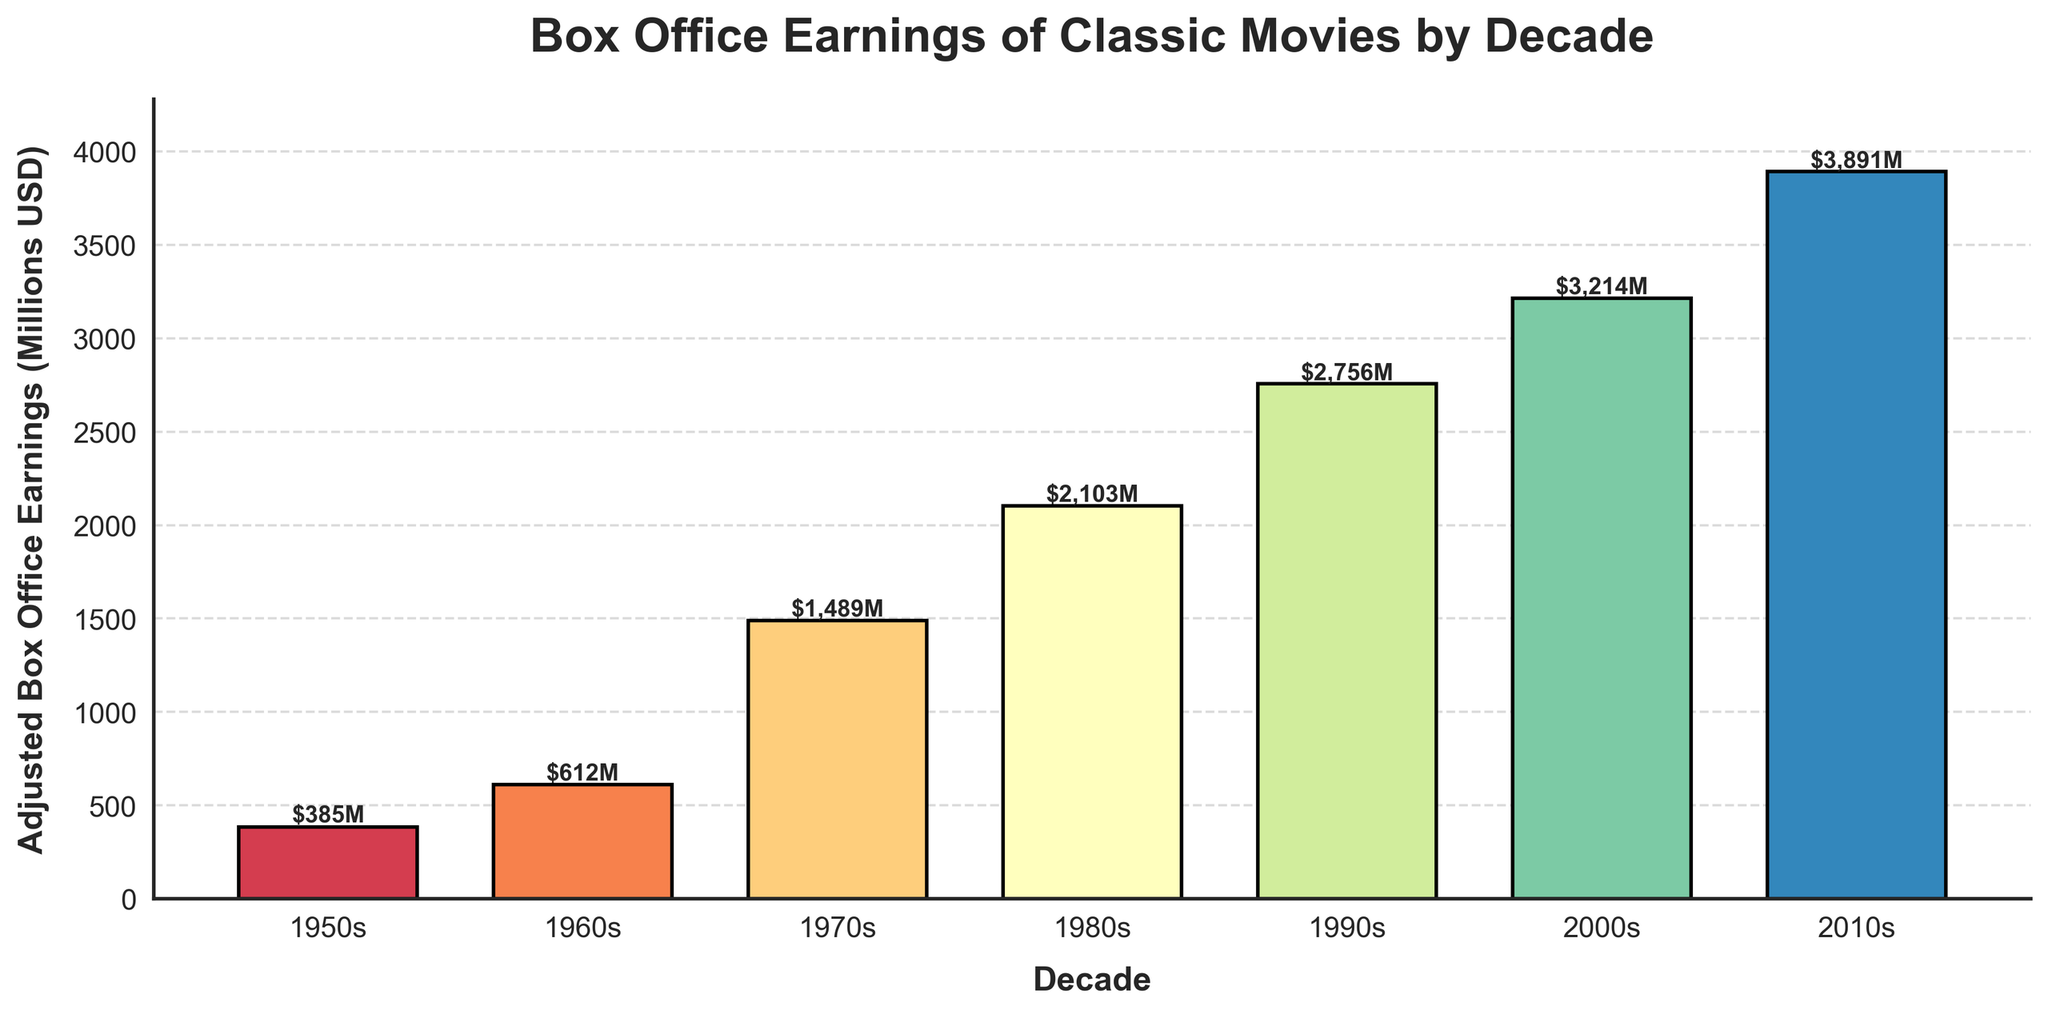Which decade had the highest box office earnings? To find the highest box office earnings, look for the bar that is the tallest. The decade of 2010s has the tallest bar.
Answer: 2010s Which decade had the lowest box office earnings? To find the lowest box office earnings, look for the bar that is the shortest. The 1950s decade has the shortest bar.
Answer: 1950s What is the total box office earnings from the 1970s and 1980s? Sum the adjusted box office earnings of the 1970s (1489M) and 1980s (2103M): 1489 + 2103 = 3592.
Answer: 3592M How much more did movies earn in the 2000s compared to the 1950s? Subtract the 1950s earnings from the 2000s earnings: 3214M - 385M = 2829M.
Answer: 2829M What is the average box office earnings per decade? Sum the earnings of all decades and divide by the number of decades: (385 + 612 + 1489 + 2103 + 2756 + 3214 + 3891) / 7 ≈ 2065.71.
Answer: 2065.71M Which decades had box office earnings greater than 2000 million USD? Identify the decades whose earnings are greater than 2000M by checking the height of the bars: 1980s, 1990s, 2000s, and 2010s.
Answer: 1980s, 1990s, 2000s, 2010s By how much did the box office earnings increase from the 1960s to the 1970s? Subtract the 1960s earnings from the 1970s earnings: 1489M - 612M = 877M.
Answer: 877M What is the difference in box office earnings between the 1990s and 2000s? Subtract the 1990s earnings from the 2000s earnings: 3214M - 2756M = 458M.
Answer: 458M How do the earnings of the 1980s compare to the 1950s? Compare the values of the 1980s (2103M) and 1950s (385M). The 1980s earnings are significantly higher.
Answer: 1980s > 1950s 